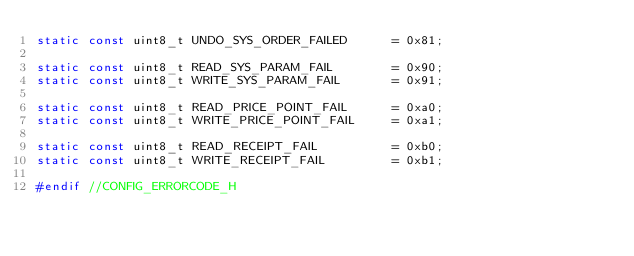<code> <loc_0><loc_0><loc_500><loc_500><_C_>static const uint8_t UNDO_SYS_ORDER_FAILED      = 0x81;

static const uint8_t READ_SYS_PARAM_FAIL        = 0x90;
static const uint8_t WRITE_SYS_PARAM_FAIL       = 0x91;

static const uint8_t READ_PRICE_POINT_FAIL      = 0xa0;
static const uint8_t WRITE_PRICE_POINT_FAIL     = 0xa1;

static const uint8_t READ_RECEIPT_FAIL          = 0xb0;
static const uint8_t WRITE_RECEIPT_FAIL         = 0xb1;

#endif //CONFIG_ERRORCODE_H</code> 